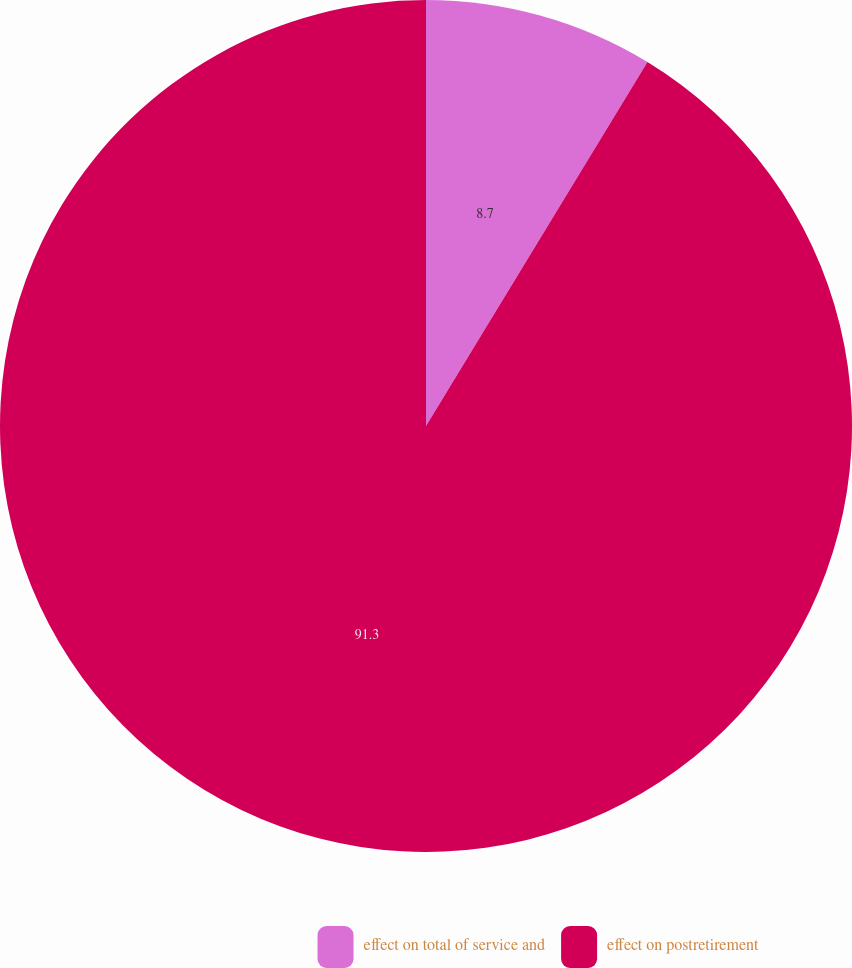Convert chart to OTSL. <chart><loc_0><loc_0><loc_500><loc_500><pie_chart><fcel>effect on total of service and<fcel>effect on postretirement<nl><fcel>8.7%<fcel>91.3%<nl></chart> 